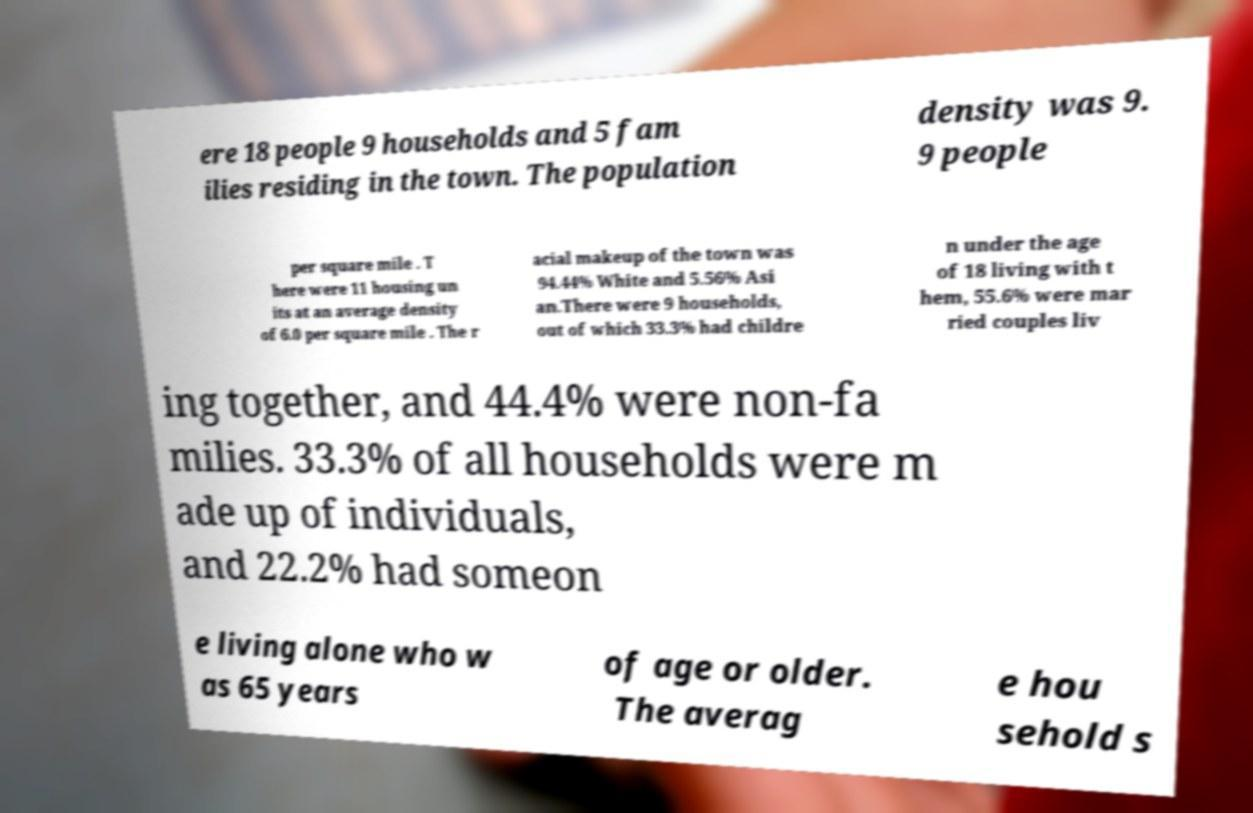Please identify and transcribe the text found in this image. ere 18 people 9 households and 5 fam ilies residing in the town. The population density was 9. 9 people per square mile . T here were 11 housing un its at an average density of 6.0 per square mile . The r acial makeup of the town was 94.44% White and 5.56% Asi an.There were 9 households, out of which 33.3% had childre n under the age of 18 living with t hem, 55.6% were mar ried couples liv ing together, and 44.4% were non-fa milies. 33.3% of all households were m ade up of individuals, and 22.2% had someon e living alone who w as 65 years of age or older. The averag e hou sehold s 